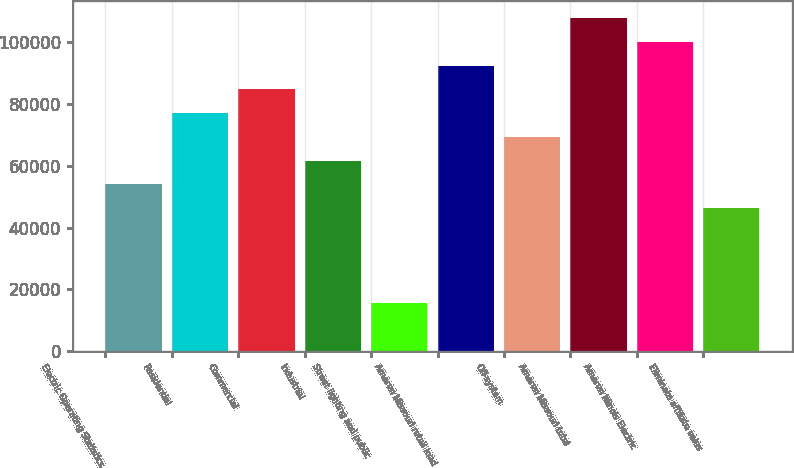Convert chart. <chart><loc_0><loc_0><loc_500><loc_500><bar_chart><fcel>Electric Operating Statistics<fcel>Residential<fcel>Commercial<fcel>Industrial<fcel>Street lighting and public<fcel>Ameren Missouri retail load<fcel>Off-system<fcel>Ameren Missouri total<fcel>Ameren Illinois Electric<fcel>Eliminate affiliate sales<nl><fcel>53973.9<fcel>77064<fcel>84760.7<fcel>61670.6<fcel>15490.4<fcel>92457.4<fcel>69367.3<fcel>107851<fcel>100154<fcel>46277.2<nl></chart> 